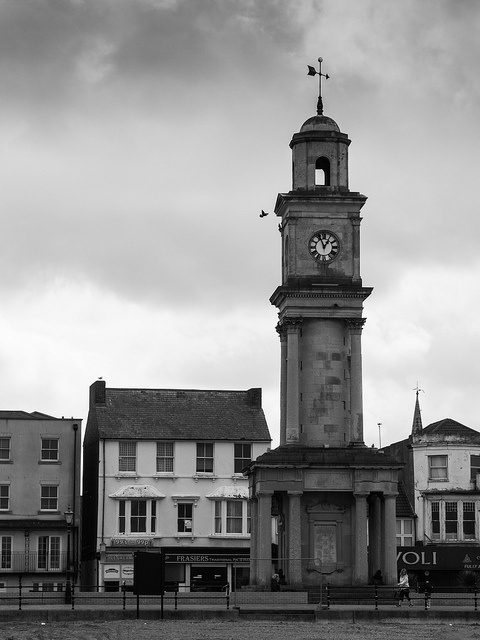Describe the objects in this image and their specific colors. I can see clock in gray, black, darkgray, and lightgray tones, people in gray, black, darkgray, and lightgray tones, people in black, gray, and darkgray tones, and bird in gray, black, lightgray, and darkgray tones in this image. 